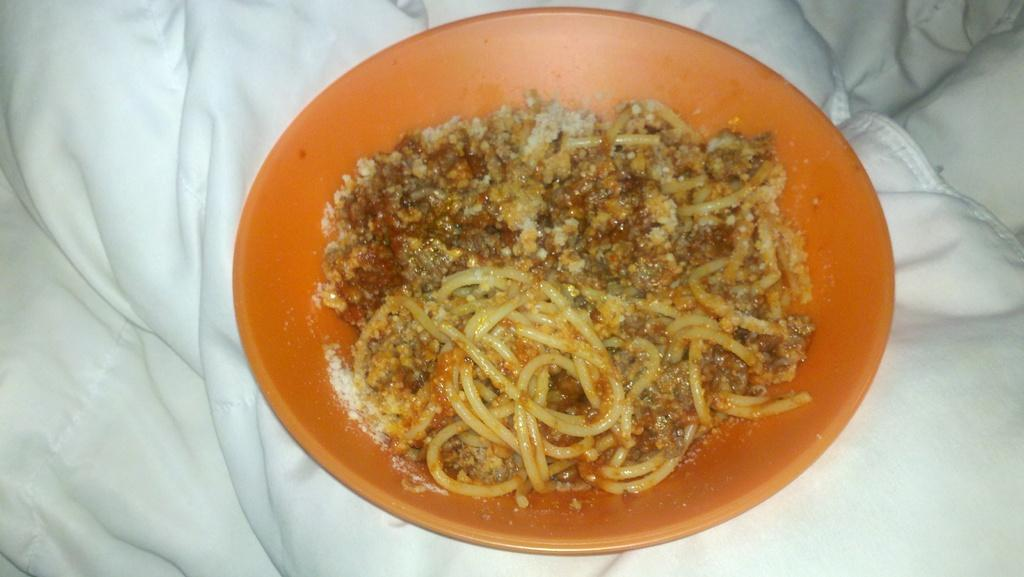What color is the bowl that is visible in the image? There is an orange bowl in the image. What is inside the bowl in the image? The bowl contains food. What type of toothbrush is depicted in the image? There is no toothbrush present in the image. What historical event is being commemorated in the image? The image does not depict any historical event or commemoration. 